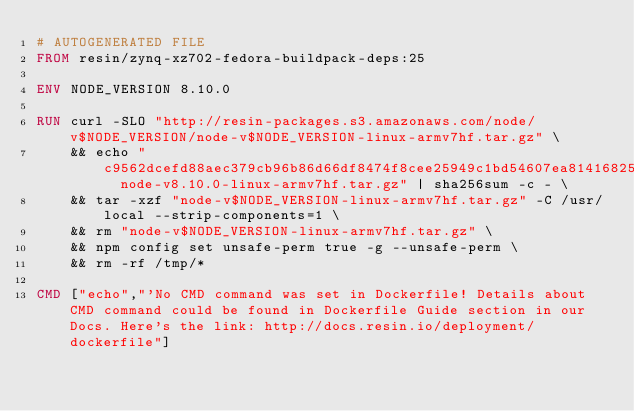Convert code to text. <code><loc_0><loc_0><loc_500><loc_500><_Dockerfile_># AUTOGENERATED FILE
FROM resin/zynq-xz702-fedora-buildpack-deps:25

ENV NODE_VERSION 8.10.0

RUN curl -SLO "http://resin-packages.s3.amazonaws.com/node/v$NODE_VERSION/node-v$NODE_VERSION-linux-armv7hf.tar.gz" \
	&& echo "c9562dcefd88aec379cb96b86d66df8474f8cee25949c1bd54607ea814168259  node-v8.10.0-linux-armv7hf.tar.gz" | sha256sum -c - \
	&& tar -xzf "node-v$NODE_VERSION-linux-armv7hf.tar.gz" -C /usr/local --strip-components=1 \
	&& rm "node-v$NODE_VERSION-linux-armv7hf.tar.gz" \
	&& npm config set unsafe-perm true -g --unsafe-perm \
	&& rm -rf /tmp/*

CMD ["echo","'No CMD command was set in Dockerfile! Details about CMD command could be found in Dockerfile Guide section in our Docs. Here's the link: http://docs.resin.io/deployment/dockerfile"]
</code> 